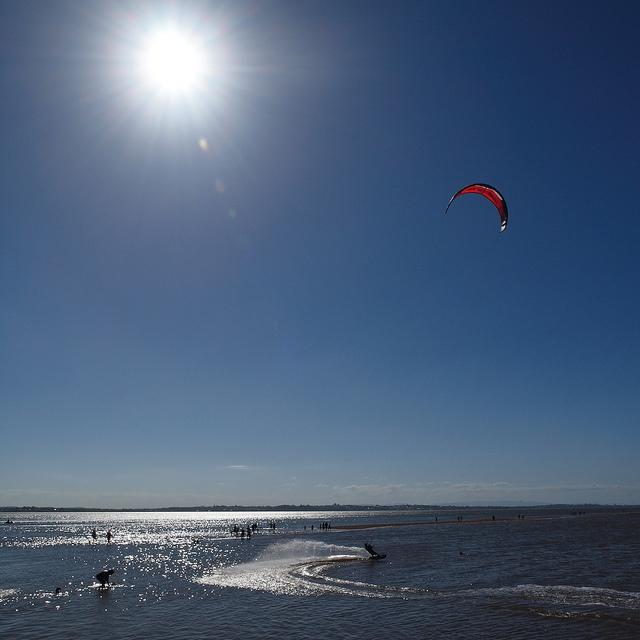Is the sun shining brightly in the sky?
Give a very brief answer. Yes. How far up is the sail?
Concise answer only. 50 feet. Is that a kite?
Answer briefly. Yes. What is the weather like?
Write a very short answer. Sunny. 